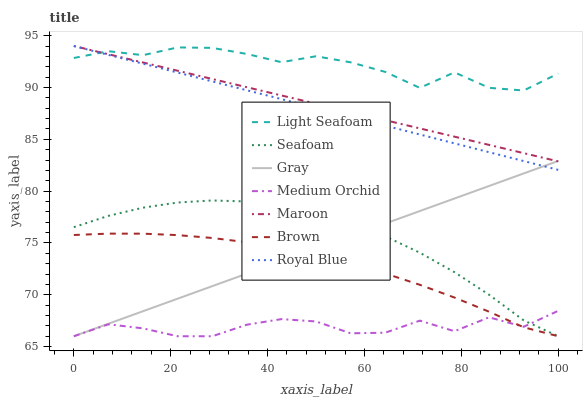Does Medium Orchid have the minimum area under the curve?
Answer yes or no. Yes. Does Light Seafoam have the maximum area under the curve?
Answer yes or no. Yes. Does Brown have the minimum area under the curve?
Answer yes or no. No. Does Brown have the maximum area under the curve?
Answer yes or no. No. Is Maroon the smoothest?
Answer yes or no. Yes. Is Medium Orchid the roughest?
Answer yes or no. Yes. Is Brown the smoothest?
Answer yes or no. No. Is Brown the roughest?
Answer yes or no. No. Does Maroon have the lowest value?
Answer yes or no. No. Does Brown have the highest value?
Answer yes or no. No. Is Gray less than Light Seafoam?
Answer yes or no. Yes. Is Light Seafoam greater than Seafoam?
Answer yes or no. Yes. Does Gray intersect Light Seafoam?
Answer yes or no. No. 